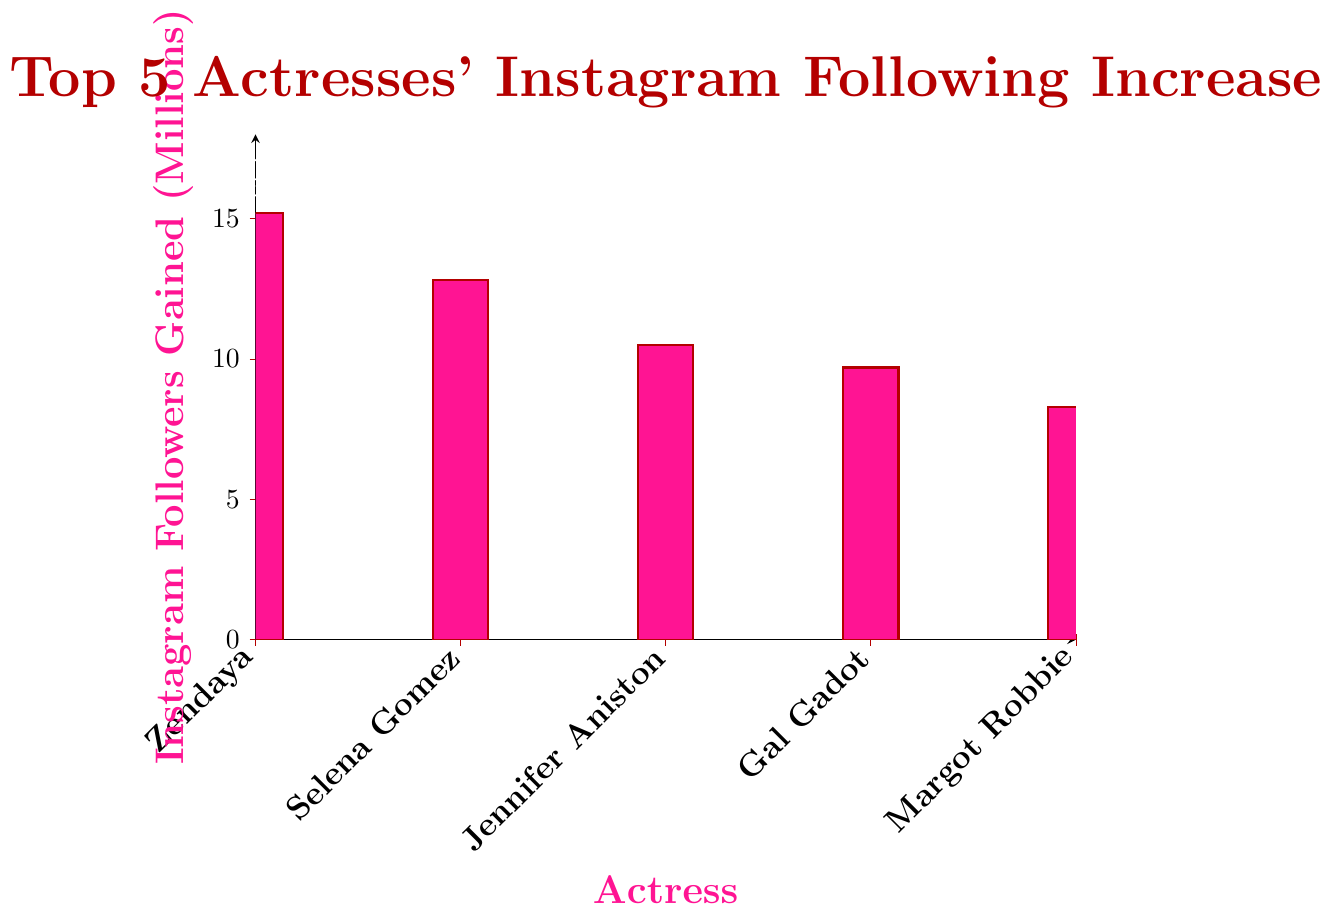What's the total increase in Instagram followers for all five actresses combined? To find the total, sum up the increases: 15.2 (Zendaya) + 12.8 (Selena Gomez) + 10.5 (Jennifer Aniston) + 9.7 (Gal Gadot) + 8.3 (Margot Robbie). The total is 56.5 million.
Answer: 56.5 million Who gained the most Instagram followers in the past year? Look at the bar with the greatest height. Zendaya's bar is the tallest, indicating she has the highest increase in followers.
Answer: Zendaya How does Margot Robbie's follower growth compare to Jennifer Aniston's? Compare the heights of the bars for Margot Robbie and Jennifer Aniston. Jennifer Aniston's bar is higher than Margot Robbie's, meaning Jennifer Aniston gained more followers.
Answer: Jennifer Aniston gained more What's the average increase in Instagram followers among these actresses? Calculate the average by summing the amounts and dividing by the number of actresses. The total is 56.5 million, and there are 5 actresses. So, 56.5 / 5 = 11.3 million.
Answer: 11.3 million By how much does Zendaya's follower growth exceed Gal Gadot's? Subtract Gal Gadot's increase from Zendaya's: 15.2 (Zendaya) - 9.7 (Gal Gadot) = 5.5 million.
Answer: 5.5 million What's the difference in follower growth between Selena Gomez and Margot Robbie? Subtract Margot Robbie's increase from Selena Gomez's: 12.8 (Selena Gomez) - 8.3 (Margot Robbie) = 4.5 million.
Answer: 4.5 million Which two actresses had the smallest difference in their follower growth? Calculate the differences between adjacent follower growths and compare them: 15.2 - 12.8 = 2.4, 12.8 - 10.5 = 2.3, 10.5 - 9.7 = 0.8, 9.7 - 8.3 = 1.4. The smallest difference is between Jennifer Aniston and Gal Gadot (0.8 million).
Answer: Jennifer Aniston and Gal Gadot 